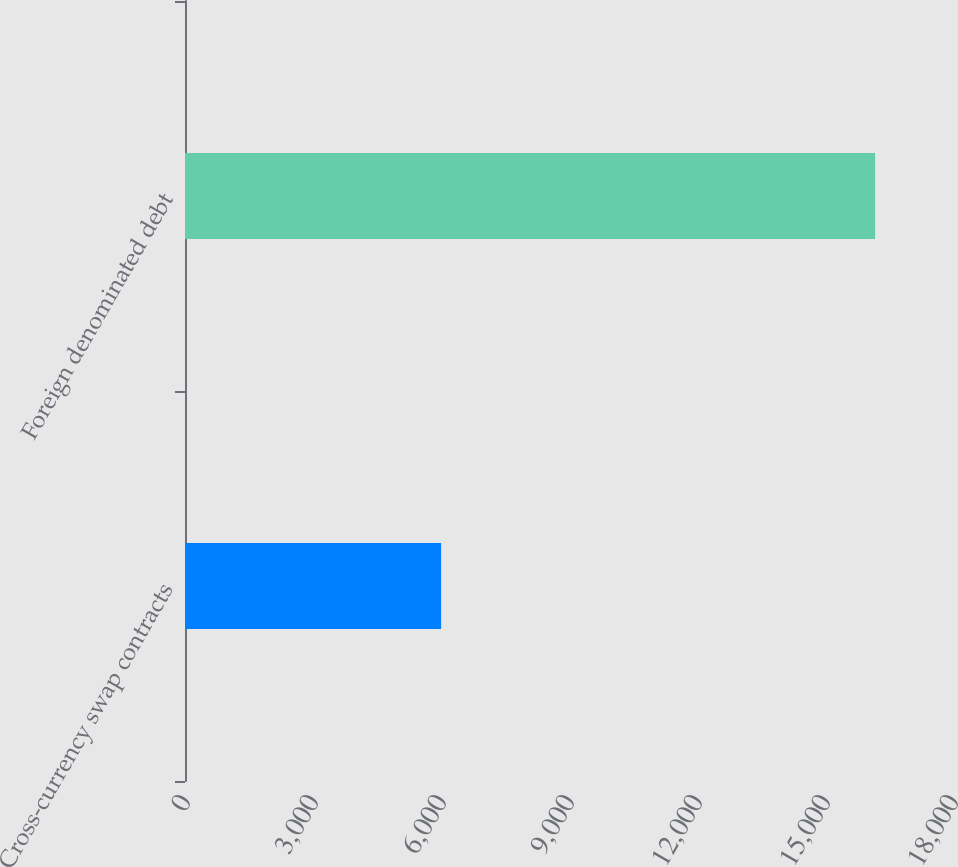<chart> <loc_0><loc_0><loc_500><loc_500><bar_chart><fcel>Cross-currency swap contracts<fcel>Foreign denominated debt<nl><fcel>6003<fcel>16175<nl></chart> 